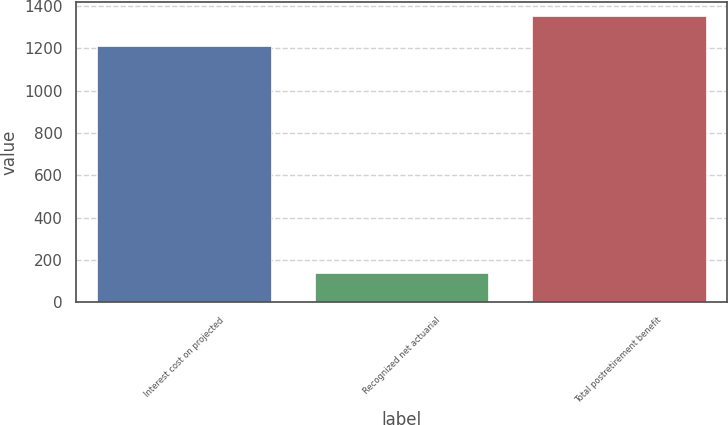<chart> <loc_0><loc_0><loc_500><loc_500><bar_chart><fcel>Interest cost on projected<fcel>Recognized net actuarial<fcel>Total postretirement benefit<nl><fcel>1213<fcel>139<fcel>1352<nl></chart> 